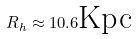Convert formula to latex. <formula><loc_0><loc_0><loc_500><loc_500>R _ { h } \approx 1 0 . 6 \text {Kpc}</formula> 